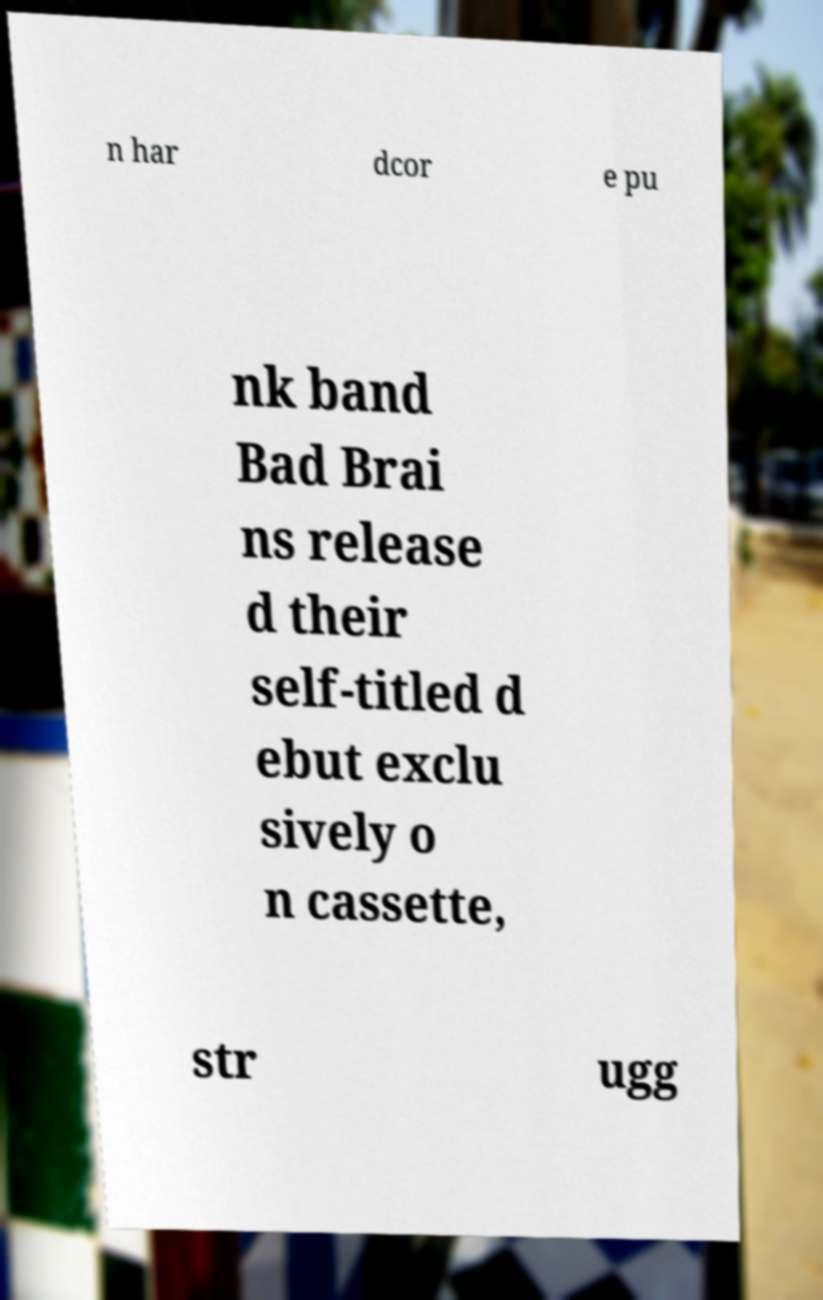Could you extract and type out the text from this image? n har dcor e pu nk band Bad Brai ns release d their self-titled d ebut exclu sively o n cassette, str ugg 